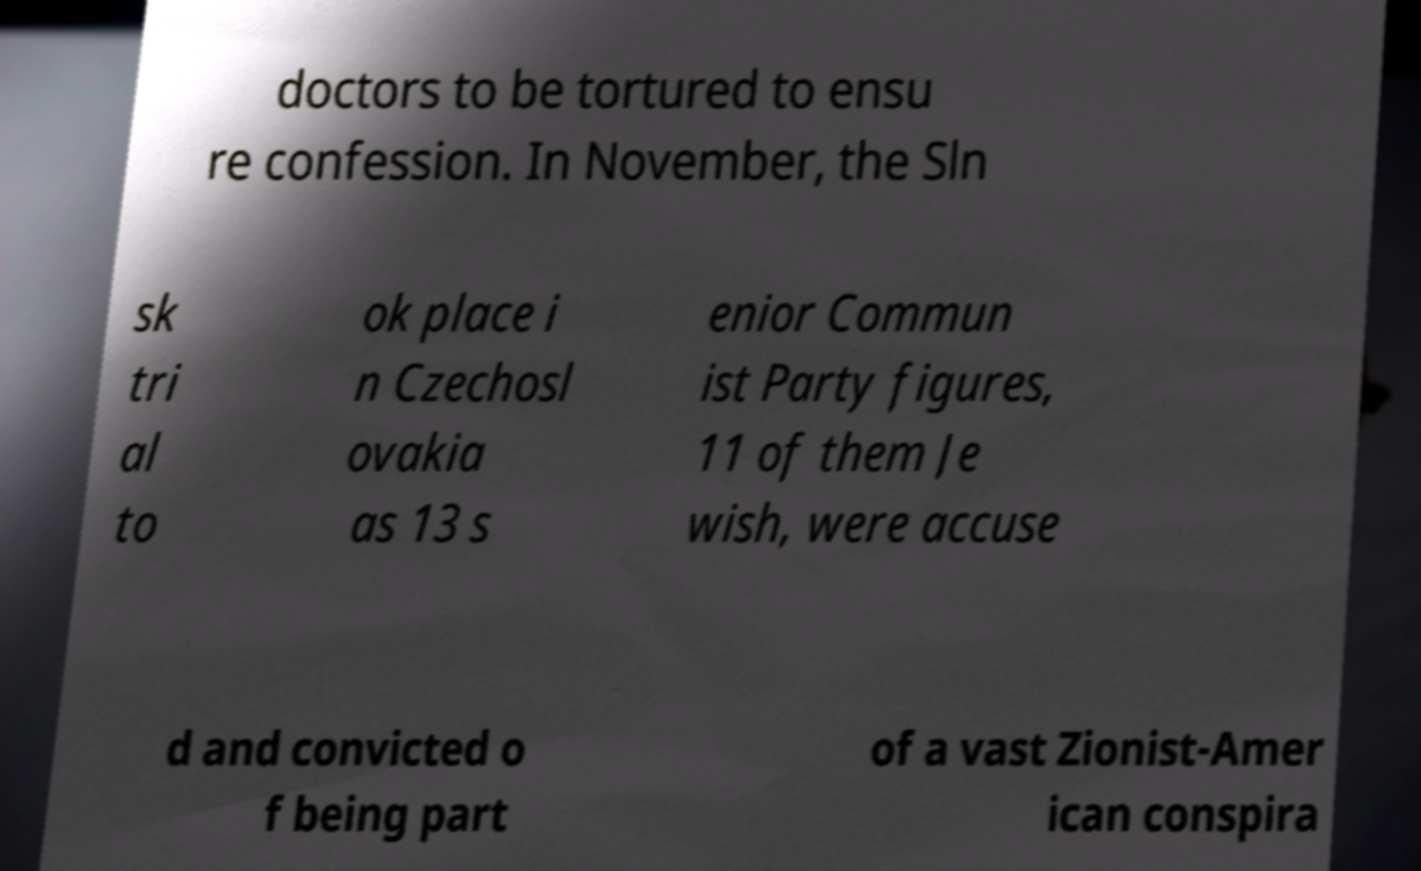What messages or text are displayed in this image? I need them in a readable, typed format. doctors to be tortured to ensu re confession. In November, the Sln sk tri al to ok place i n Czechosl ovakia as 13 s enior Commun ist Party figures, 11 of them Je wish, were accuse d and convicted o f being part of a vast Zionist-Amer ican conspira 